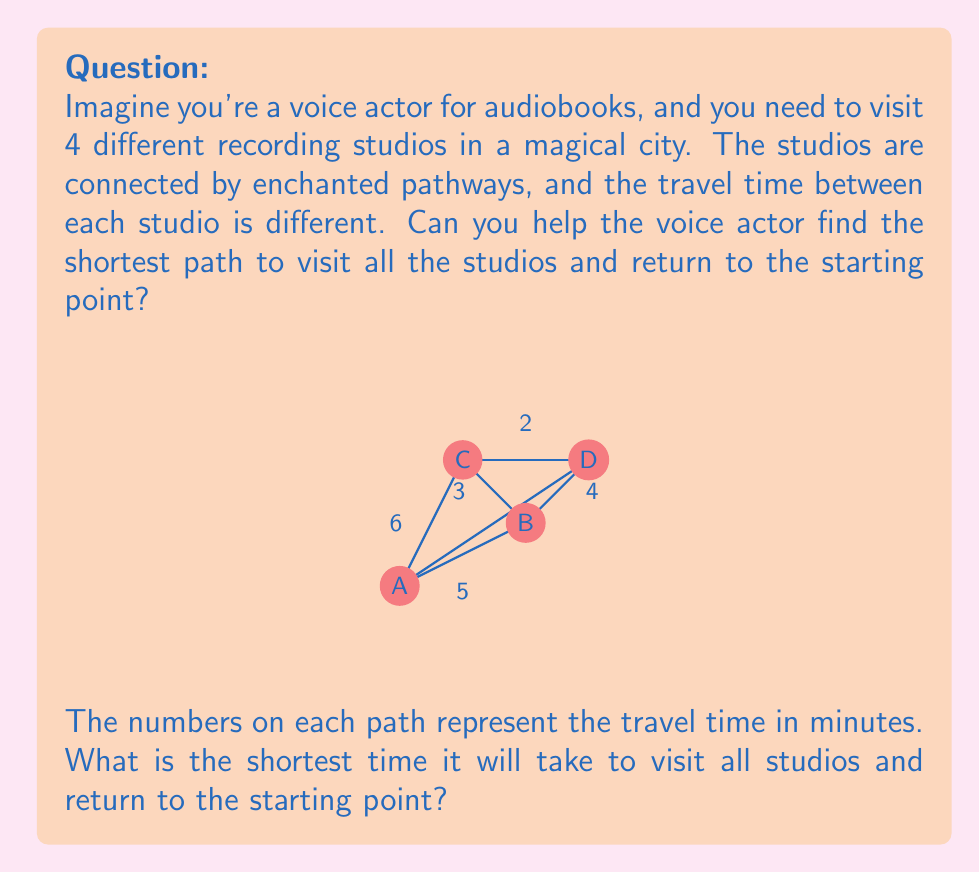Could you help me with this problem? Let's approach this step-by-step:

1) First, we need to identify all possible paths that visit each studio once and return to the starting point. These are called Hamiltonian cycles.

2) The possible Hamiltonian cycles are:
   A-B-C-D-A
   A-B-D-C-A
   A-C-B-D-A
   A-C-D-B-A
   A-D-B-C-A
   A-D-C-B-A

3) Now, let's calculate the total time for each path:

   A-B-C-D-A: $5 + 3 + 2 + 4 = 14$ minutes
   A-B-D-C-A: $5 + 4 + 2 + 6 = 17$ minutes
   A-C-B-D-A: $6 + 3 + 4 + 4 = 17$ minutes
   A-C-D-B-A: $6 + 2 + 4 + 5 = 17$ minutes
   A-D-B-C-A: $4 + 4 + 3 + 6 = 17$ minutes
   A-D-C-B-A: $4 + 2 + 3 + 5 = 14$ minutes

4) We can see that there are two paths that take the shortest time: A-B-C-D-A and A-D-C-B-A, both taking 14 minutes.

5) Therefore, the shortest time to visit all studios and return to the starting point is 14 minutes.
Answer: 14 minutes 